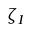<formula> <loc_0><loc_0><loc_500><loc_500>\zeta _ { I }</formula> 